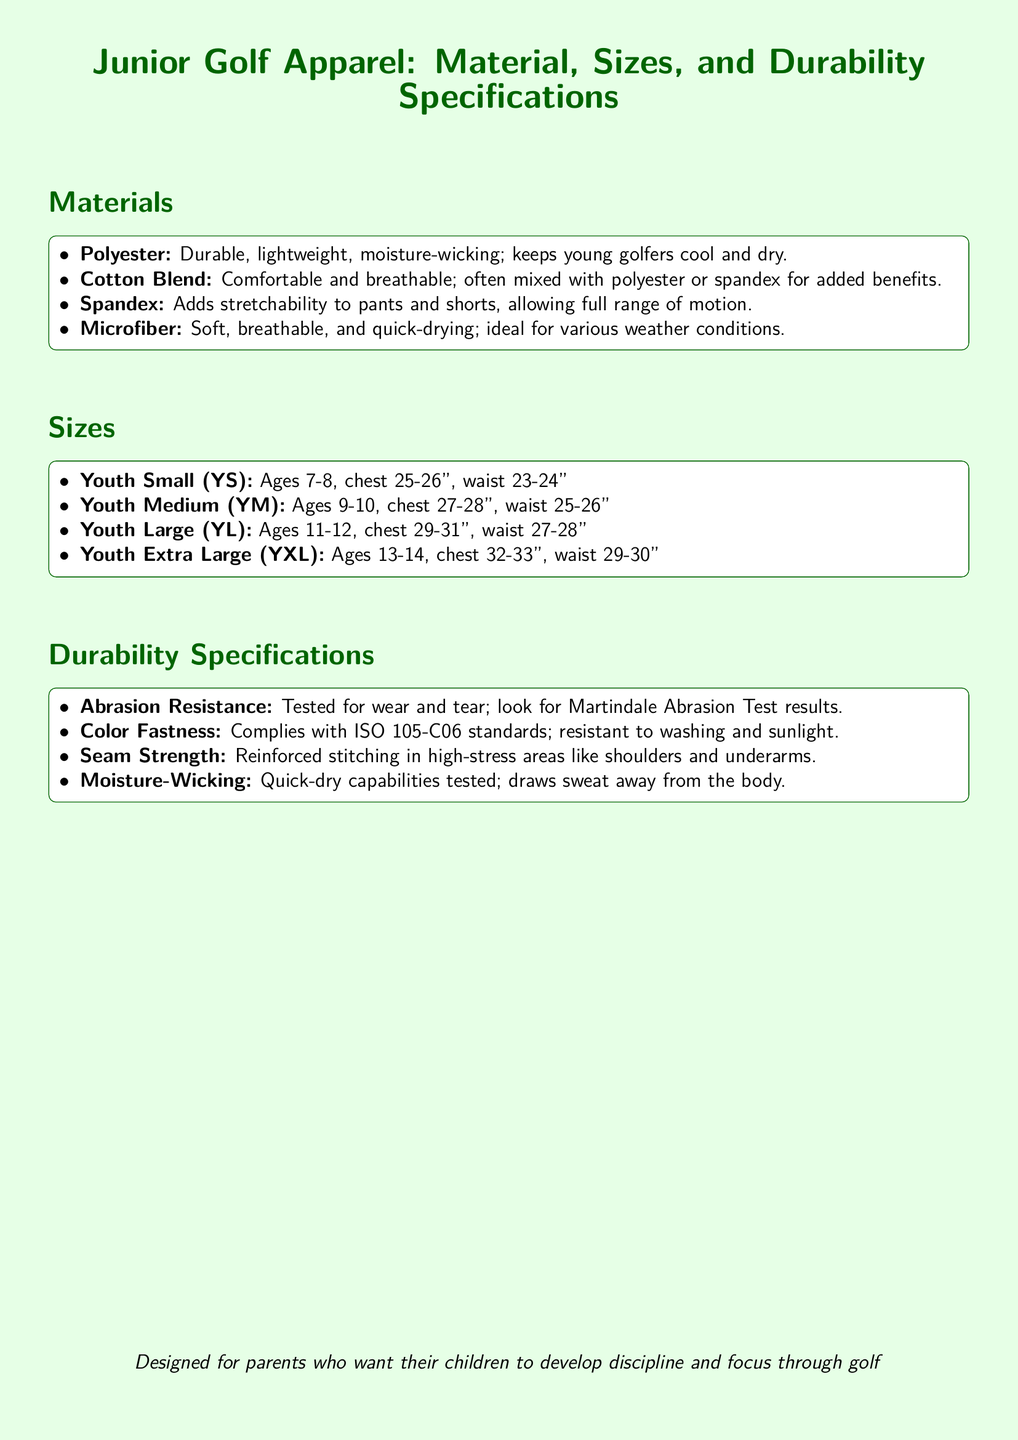What material keeps young golfers cool and dry? The material that keeps young golfers cool and dry is Polyester, which is described as durable, lightweight, and moisture-wicking.
Answer: Polyester What size is recommended for ages 11-12? The size recommended for ages 11-12 is Youth Large (YL), as specified in the size section of the document.
Answer: Youth Large (YL) What is tested for wear and tear? The document states that Abrasion Resistance is tested for wear and tear, specifically mentioning the Martindale Abrasion Test.
Answer: Abrasion Resistance Which size corresponds to a chest measurement of 27-28 inches? The size that corresponds to a chest measurement of 27-28 inches is Youth Medium (YM), as per the size chart provided.
Answer: Youth Medium (YM) What adds stretchability to pants and shorts? The document specifies that Spandex adds stretchability to pants and shorts, allowing a full range of motion.
Answer: Spandex 